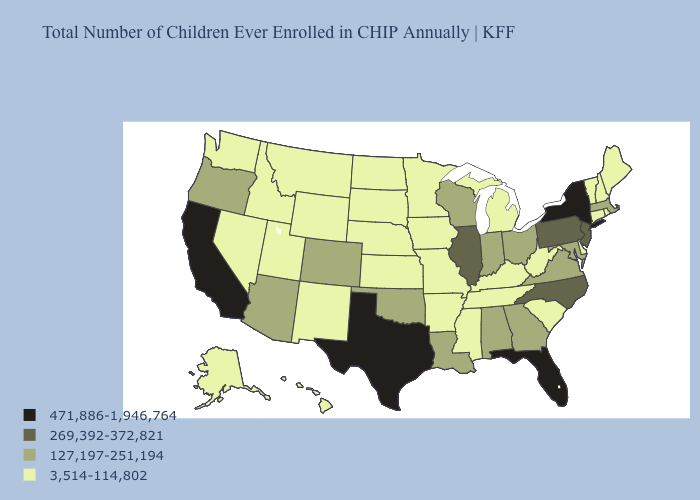Which states hav the highest value in the South?
Answer briefly. Florida, Texas. Does Arizona have the lowest value in the West?
Quick response, please. No. Which states hav the highest value in the MidWest?
Short answer required. Illinois. How many symbols are there in the legend?
Give a very brief answer. 4. Name the states that have a value in the range 127,197-251,194?
Concise answer only. Alabama, Arizona, Colorado, Georgia, Indiana, Louisiana, Maryland, Massachusetts, Ohio, Oklahoma, Oregon, Virginia, Wisconsin. Does Utah have the lowest value in the USA?
Give a very brief answer. Yes. What is the value of North Carolina?
Concise answer only. 269,392-372,821. How many symbols are there in the legend?
Be succinct. 4. What is the value of Delaware?
Write a very short answer. 3,514-114,802. What is the lowest value in the South?
Quick response, please. 3,514-114,802. Among the states that border Vermont , which have the highest value?
Keep it brief. New York. Name the states that have a value in the range 3,514-114,802?
Be succinct. Alaska, Arkansas, Connecticut, Delaware, Hawaii, Idaho, Iowa, Kansas, Kentucky, Maine, Michigan, Minnesota, Mississippi, Missouri, Montana, Nebraska, Nevada, New Hampshire, New Mexico, North Dakota, Rhode Island, South Carolina, South Dakota, Tennessee, Utah, Vermont, Washington, West Virginia, Wyoming. What is the lowest value in the USA?
Be succinct. 3,514-114,802. What is the value of Mississippi?
Answer briefly. 3,514-114,802. Name the states that have a value in the range 269,392-372,821?
Give a very brief answer. Illinois, New Jersey, North Carolina, Pennsylvania. 